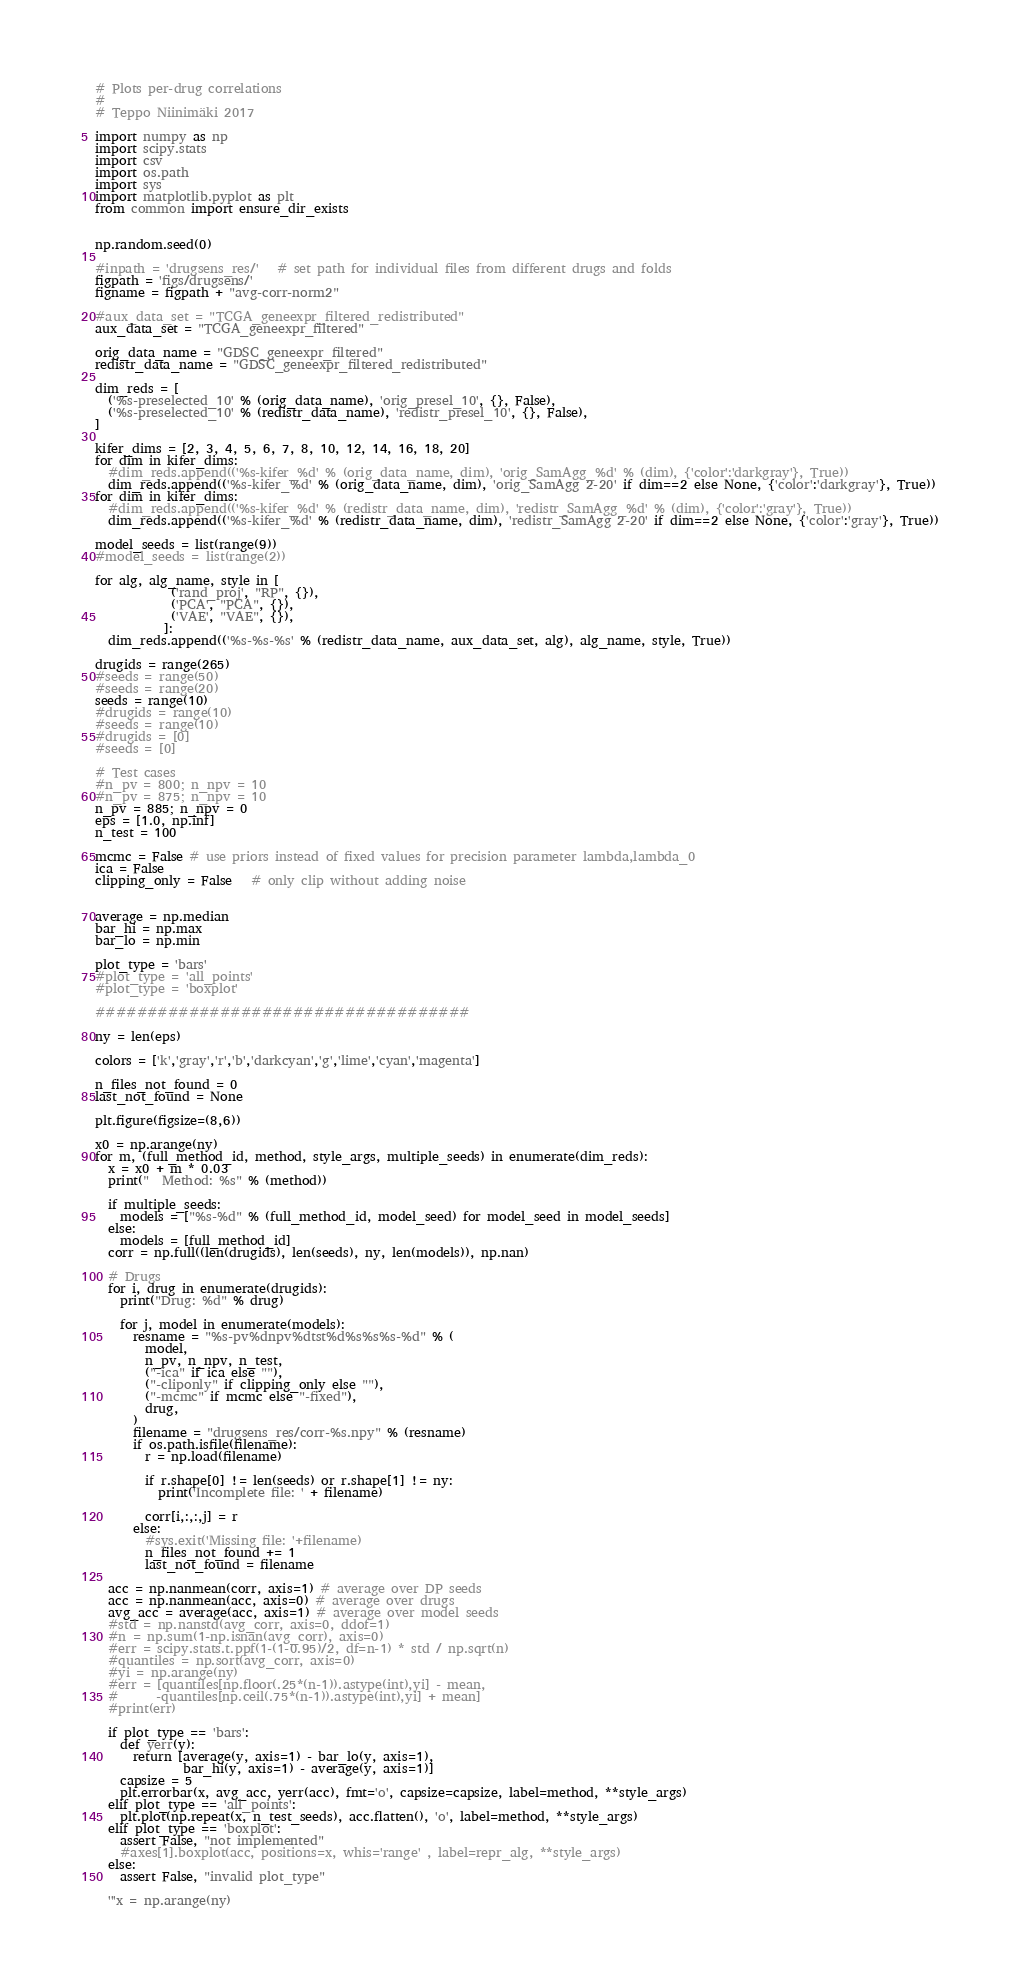<code> <loc_0><loc_0><loc_500><loc_500><_Python_># Plots per-drug correlations
#
# Teppo Niinimäki 2017

import numpy as np
import scipy.stats
import csv
import os.path
import sys
import matplotlib.pyplot as plt
from common import ensure_dir_exists


np.random.seed(0)

#inpath = 'drugsens_res/'   # set path for individual files from different drugs and folds
figpath = 'figs/drugsens/'
figname = figpath + "avg-corr-norm2"

#aux_data_set = "TCGA_geneexpr_filtered_redistributed"
aux_data_set = "TCGA_geneexpr_filtered"

orig_data_name = "GDSC_geneexpr_filtered"
redistr_data_name = "GDSC_geneexpr_filtered_redistributed"

dim_reds = [
  ('%s-preselected_10' % (orig_data_name), 'orig_presel_10', {}, False),
  ('%s-preselected_10' % (redistr_data_name), 'redistr_presel_10', {}, False),
]

kifer_dims = [2, 3, 4, 5, 6, 7, 8, 10, 12, 14, 16, 18, 20]
for dim in kifer_dims:
  #dim_reds.append(('%s-kifer_%d' % (orig_data_name, dim), 'orig_SamAgg_%d' % (dim), {'color':'darkgray'}, True))
  dim_reds.append(('%s-kifer_%d' % (orig_data_name, dim), 'orig_SamAgg 2-20' if dim==2 else None, {'color':'darkgray'}, True))
for dim in kifer_dims:
  #dim_reds.append(('%s-kifer_%d' % (redistr_data_name, dim), 'redistr_SamAgg_%d' % (dim), {'color':'gray'}, True))
  dim_reds.append(('%s-kifer_%d' % (redistr_data_name, dim), 'redistr_SamAgg 2-20' if dim==2 else None, {'color':'gray'}, True))

model_seeds = list(range(9))
#model_seeds = list(range(2))

for alg, alg_name, style in [
            ('rand_proj', "RP", {}),
            ('PCA', "PCA", {}),
            ('VAE', "VAE", {}),
           ]:
  dim_reds.append(('%s-%s-%s' % (redistr_data_name, aux_data_set, alg), alg_name, style, True))

drugids = range(265)
#seeds = range(50)
#seeds = range(20)
seeds = range(10)
#drugids = range(10)
#seeds = range(10)
#drugids = [0]
#seeds = [0]

# Test cases
#n_pv = 800; n_npv = 10 
#n_pv = 875; n_npv = 10
n_pv = 885; n_npv = 0
eps = [1.0, np.inf]
n_test = 100

mcmc = False # use priors instead of fixed values for precision parameter lambda,lambda_0
ica = False
clipping_only = False   # only clip without adding noise


average = np.median
bar_hi = np.max
bar_lo = np.min

plot_type = 'bars'
#plot_type = 'all_points'
#plot_type = 'boxplot'

####################################

ny = len(eps)

colors = ['k','gray','r','b','darkcyan','g','lime','cyan','magenta']

n_files_not_found = 0
last_not_found = None

plt.figure(figsize=(8,6))

x0 = np.arange(ny)
for m, (full_method_id, method, style_args, multiple_seeds) in enumerate(dim_reds):
  x = x0 + m * 0.03
  print("  Method: %s" % (method))

  if multiple_seeds:
    models = ["%s-%d" % (full_method_id, model_seed) for model_seed in model_seeds]
  else:
    models = [full_method_id]
  corr = np.full((len(drugids), len(seeds), ny, len(models)), np.nan)

  # Drugs
  for i, drug in enumerate(drugids):
    print("Drug: %d" % drug)

    for j, model in enumerate(models):
      resname = "%s-pv%dnpv%dtst%d%s%s%s-%d" % (
        model,
        n_pv, n_npv, n_test,
        ("-ica" if ica else ""),
        ("-cliponly" if clipping_only else ""),
        ("-mcmc" if mcmc else "-fixed"),
        drug,
      )
      filename = "drugsens_res/corr-%s.npy" % (resname)
      if os.path.isfile(filename):
        r = np.load(filename)
        
        if r.shape[0] != len(seeds) or r.shape[1] != ny:
          print('Incomplete file: ' + filename)
        
        corr[i,:,:,j] = r
      else:
        #sys.exit('Missing file: '+filename)
        n_files_not_found += 1
        last_not_found = filename

  acc = np.nanmean(corr, axis=1) # average over DP seeds
  acc = np.nanmean(acc, axis=0) # average over drugs
  avg_acc = average(acc, axis=1) # average over model seeds
  #std = np.nanstd(avg_corr, axis=0, ddof=1)
  #n = np.sum(1-np.isnan(avg_corr), axis=0)
  #err = scipy.stats.t.ppf(1-(1-0.95)/2, df=n-1) * std / np.sqrt(n)
  #quantiles = np.sort(avg_corr, axis=0)
  #yi = np.arange(ny)
  #err = [quantiles[np.floor(.25*(n-1)).astype(int),yi] - mean,
  #      -quantiles[np.ceil(.75*(n-1)).astype(int),yi] + mean]
  #print(err)

  if plot_type == 'bars':
    def yerr(y):
      return [average(y, axis=1) - bar_lo(y, axis=1),
              bar_hi(y, axis=1) - average(y, axis=1)]
    capsize = 5
    plt.errorbar(x, avg_acc, yerr(acc), fmt='o', capsize=capsize, label=method, **style_args)
  elif plot_type == 'all_points':
    plt.plot(np.repeat(x, n_test_seeds), acc.flatten(), 'o', label=method, **style_args)
  elif plot_type == 'boxplot':
    assert False, "not implemented"
    #axes[1].boxplot(acc, positions=x, whis='range' , label=repr_alg, **style_args)
  else:
    assert False, "invalid plot_type"

  '''x = np.arange(ny)</code> 